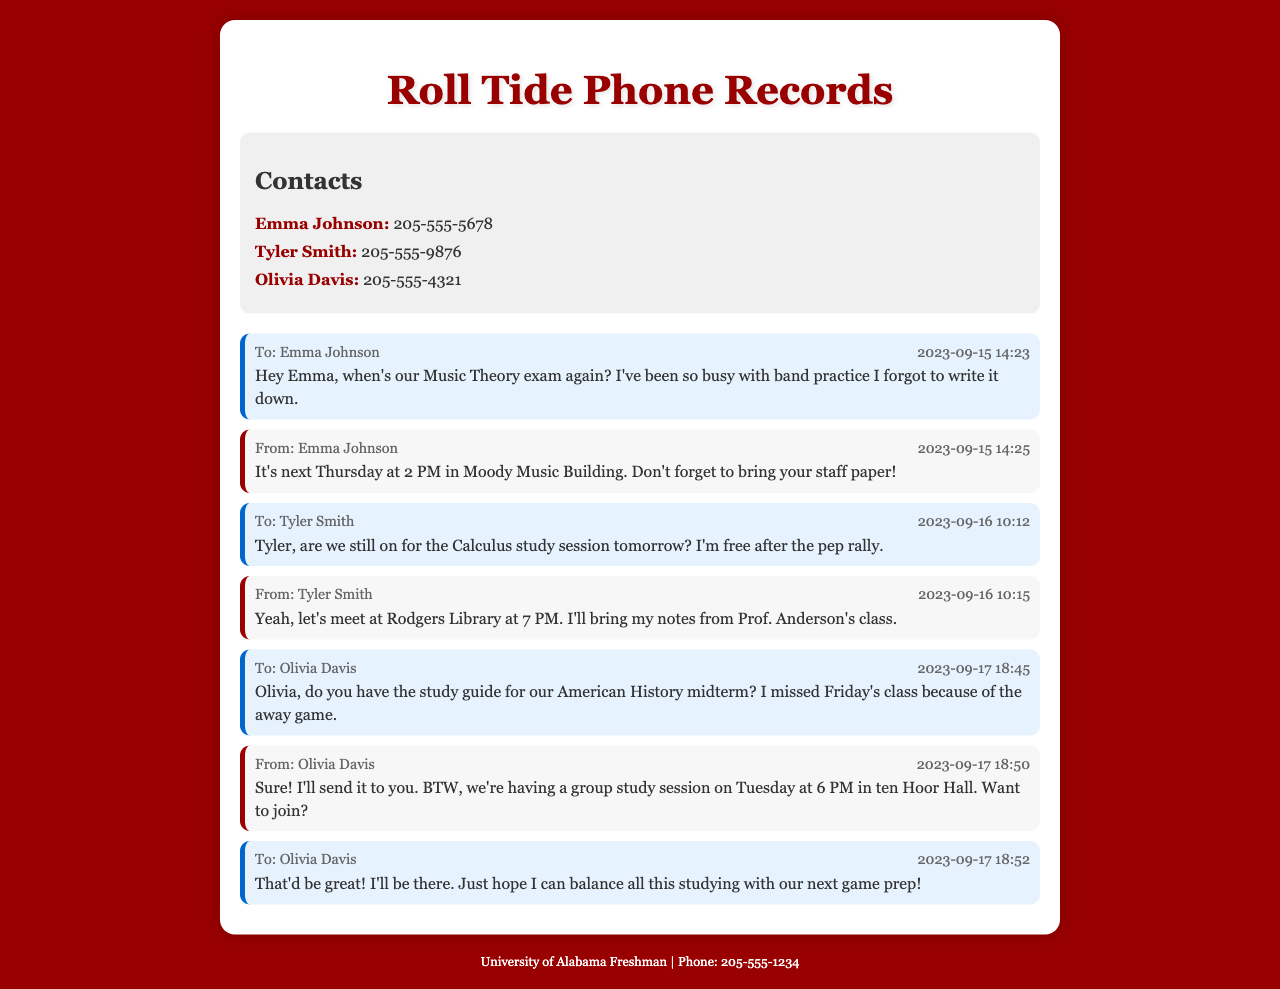what is the name of the first contact? The first contact listed in the document is Emma Johnson.
Answer: Emma Johnson when is the Music Theory exam? The message from Emma Johnson indicates the exam is next Thursday at 2 PM.
Answer: next Thursday at 2 PM what location is mentioned for the Calculus study session? Tyler Smith stated that they would meet at Rodgers Library for the study session.
Answer: Rodgers Library what time is the group study session on Tuesday? Olivia Davis mentioned that the group study session is at 6 PM.
Answer: 6 PM who is bringing notes to the Calculus study session? Tyler Smith confirmed that he would bring his notes from Prof. Anderson's class.
Answer: Tyler Smith how did Olivia Davis ask to share the study guide? Olivia offered to send the study guide to the person who requested it.
Answer: send it to you what specific item should be brought to the Music Theory exam? Emma Johnson reminded the recipient to bring staff paper to the exam.
Answer: staff paper who sent the last message in the conversation? The last outgoing message was sent by the user to Olivia Davis.
Answer: user (the freshman student) which class's notes is Tyler bringing to the study session? Tyler specifically mentioned bringing notes from Prof. Anderson's class.
Answer: Prof. Anderson's class 